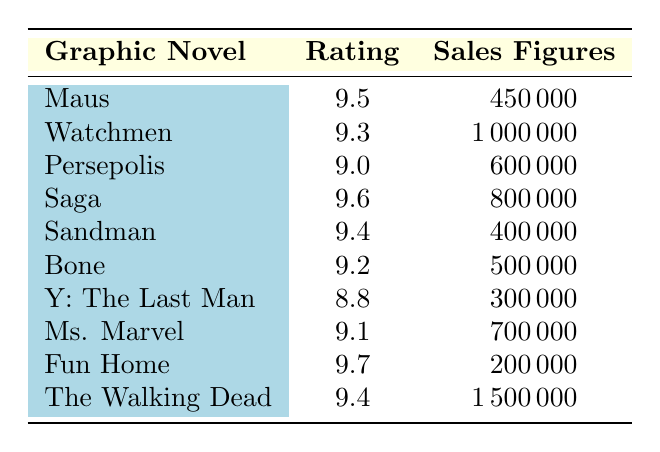What is the rating of "Fun Home"? From the table, we can locate "Fun Home" and see that it has a rating listed as 9.7.
Answer: 9.7 How many copies did "The Walking Dead" sell? By looking at the row for "The Walking Dead" in the table, we can see that the sales figures are 1,500,000.
Answer: 1,500,000 Which graphic novel has the lowest rating? Observing the rating column, we see that "Y: The Last Man" has the lowest rating of 8.8 compared to others.
Answer: Y: The Last Man What is the average rating of the graphic novels listed? To find the average, we first add all the ratings: (9.5 + 9.3 + 9.0 + 9.6 + 9.4 + 9.2 + 8.8 + 9.1 + 9.7 + 9.4) = 95.0. There are 10 graphic novels, so the average rating is 95.0 / 10 = 9.5.
Answer: 9.5 Do any graphic novels have sales figures less than 500,000? Checking the sales figures in the table, "Maus" (450,000), "Sandman" (400,000), and "Y: The Last Man" (300,000) have sales less than 500,000.
Answer: Yes Which graphic novel has both a rating above 9.5 and sales figures over 700,000? We analyze the table and find "Saga" with a rating of 9.6 and sales of 800,000, which meets both criteria.
Answer: Saga What is the sales difference between the highest-selling and the lowest-selling graphic novel? The highest-selling graphic novel is "The Walking Dead" with 1,500,000 sales and the lowest is "Fun Home" with 200,000 sales. The difference is 1,500,000 - 200,000 = 1,300,000.
Answer: 1,300,000 How many graphic novels have ratings above 9.4? By checking the ratings, we identify that "Maus" (9.5), "Saga" (9.6), "Fun Home" (9.7), "Watchmen" (9.3), and "Sandman" (9.4) fit this criteria. Only "Maus," "Saga," and "Fun Home" have ratings above 9.4, totaling three graphic novels.
Answer: 3 Is "Ms. Marvel" rated higher than "Bone"? Comparing the ratings, "Ms. Marvel" has a rating of 9.1 while "Bone" has a rating of 9.2. Therefore, "Ms. Marvel" is not rated higher.
Answer: No 